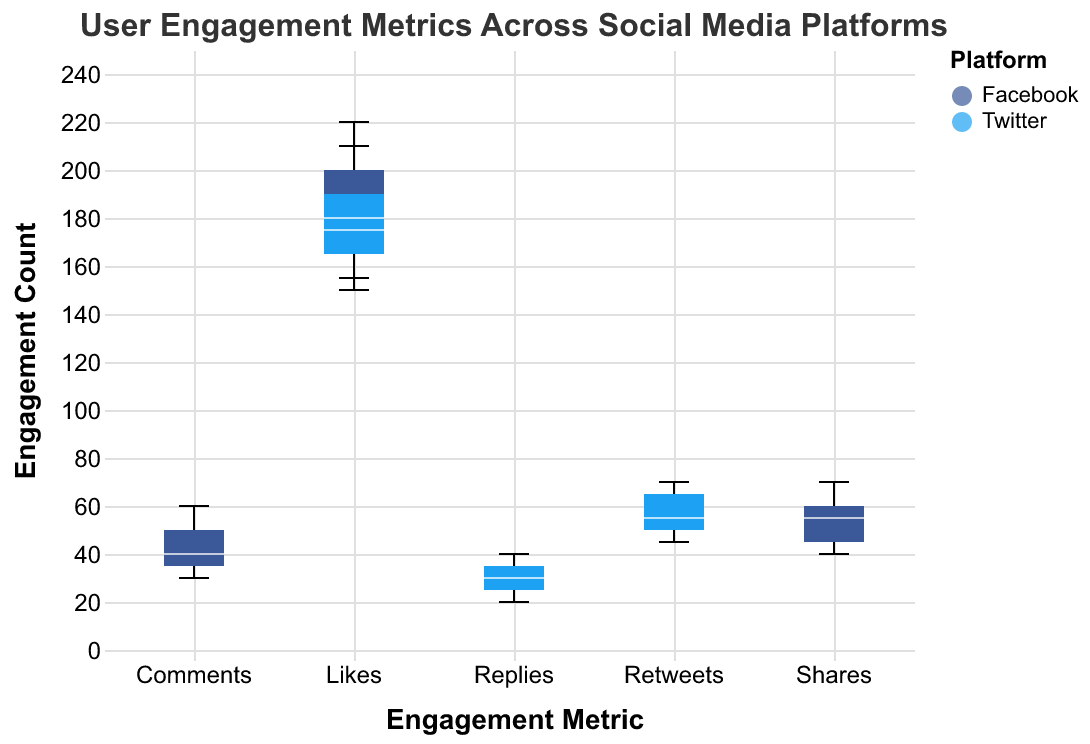What is the title of the plot? The title of the plot is located at the top of the figure and reads "User Engagement Metrics Across Social Media Platforms"
Answer: User Engagement Metrics Across Social Media Platforms Which social media platforms are compared in the figure? The platforms can be identified by the colors in the legend. The plot compares Facebook and Twitter.
Answer: Facebook and Twitter What is the color used to represent Twitter in the plot? The legend corresponding to the colors indicates that Twitter is represented by a light blue color.
Answer: Light blue What metric has the highest median engagement on Facebook? To find the highest median engagement for Facebook, look at the median lines within Facebook's box plots for "Likes," "Shares," and "Comments." The median for "Likes" appears to be the highest.
Answer: Likes What is the range of engagement values for Twitter Retweets? The range can be found by looking at the endpoints of the box plot's whiskers for "Retweets" under Twitter. The range is from 45 to 70.
Answer: 45 to 70 How does the median value of Facebook Shares compare to Twitter Retweets? Compare the median lines of the box plots for Facebook Shares and Twitter Retweets. Facebook Shares have a median around 55, and Twitter Retweets also have a median around 55.
Answer: Equal Which metric has the largest interquartile range (IQR) on Facebook? The IQR can be determined by the width of the box in the box plot. Compare the lengths of the boxes for "Likes," "Shares," and "Comments" on Facebook. The "Likes" box appears to be the widest.
Answer: Likes Are there any outliers for Twitter Replies? Outliers are indicated by points outside the whiskers. Checking the "Replies" metric for Twitter, there are no points outside the whiskers, so there are no outliers.
Answer: No What is the interquartile range (IQR) for Facebook Comments? The interquartile range is the distance between the first and third quartiles (the bottom and top of the box). For Facebook Comments, the bottom of the box is at 35 and the top is at 50, so the IQR is 50 - 35 = 15.
Answer: 15 Which platform has a higher maximum engagement value for the "Likes" metric? Look at the maximum whisker for "Likes" metric on both platforms. Facebook's maximum is 220, and Twitter's is 210. Facebook has the higher maximum engagement value for likes.
Answer: Facebook 